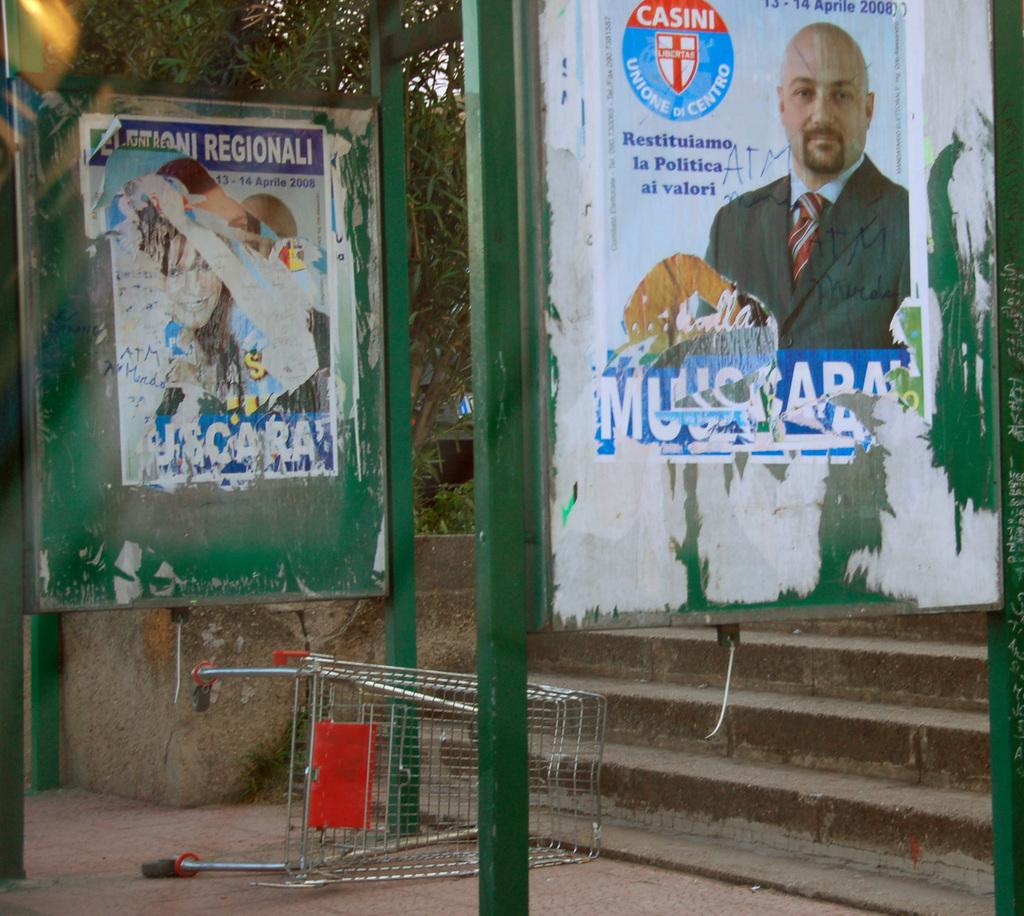What is the brand shown on the poster on the right?
Offer a terse response. Casini. 